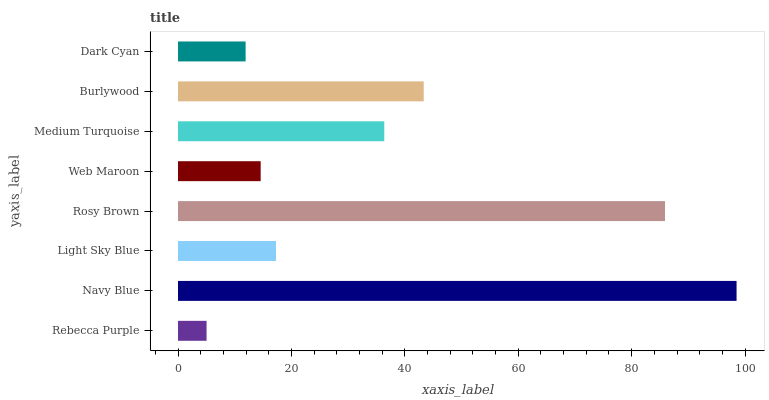Is Rebecca Purple the minimum?
Answer yes or no. Yes. Is Navy Blue the maximum?
Answer yes or no. Yes. Is Light Sky Blue the minimum?
Answer yes or no. No. Is Light Sky Blue the maximum?
Answer yes or no. No. Is Navy Blue greater than Light Sky Blue?
Answer yes or no. Yes. Is Light Sky Blue less than Navy Blue?
Answer yes or no. Yes. Is Light Sky Blue greater than Navy Blue?
Answer yes or no. No. Is Navy Blue less than Light Sky Blue?
Answer yes or no. No. Is Medium Turquoise the high median?
Answer yes or no. Yes. Is Light Sky Blue the low median?
Answer yes or no. Yes. Is Light Sky Blue the high median?
Answer yes or no. No. Is Navy Blue the low median?
Answer yes or no. No. 